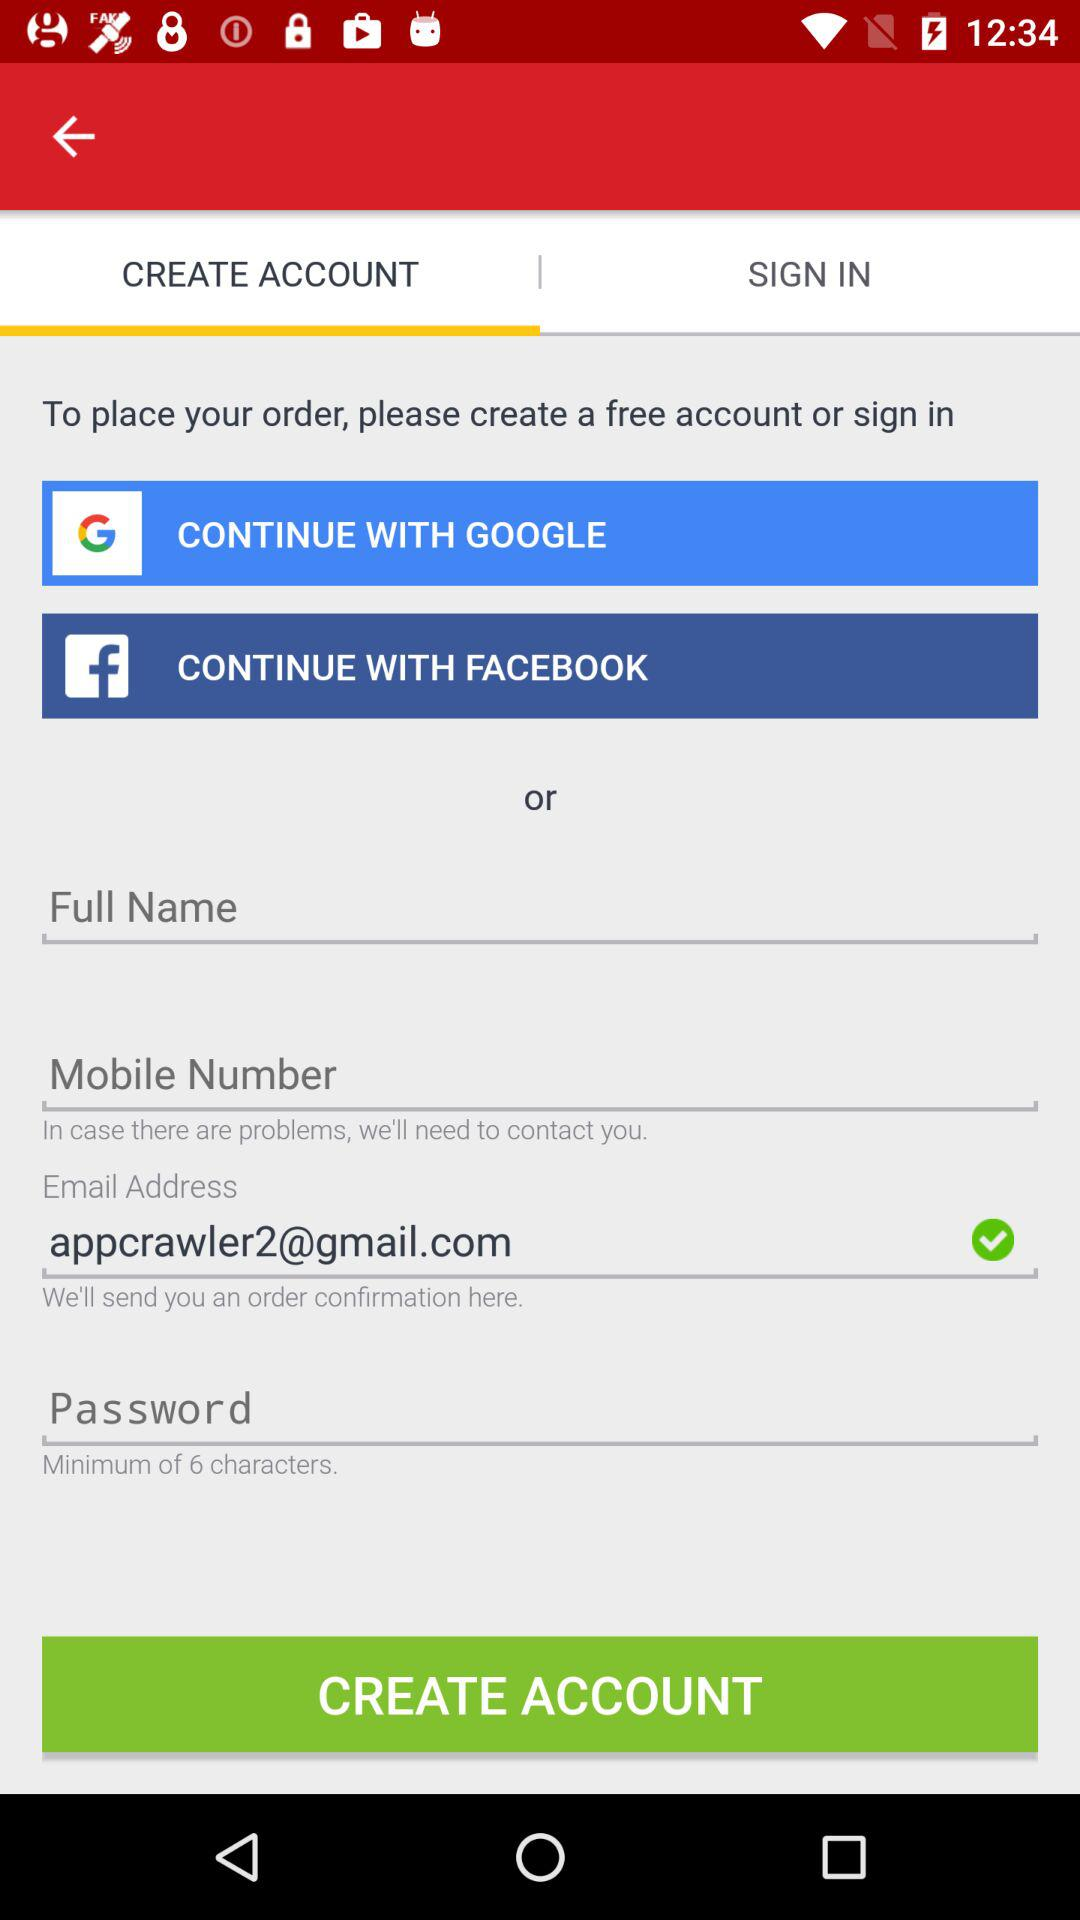What is the given email address? The given email address is appcrawler2@gmail.com. 